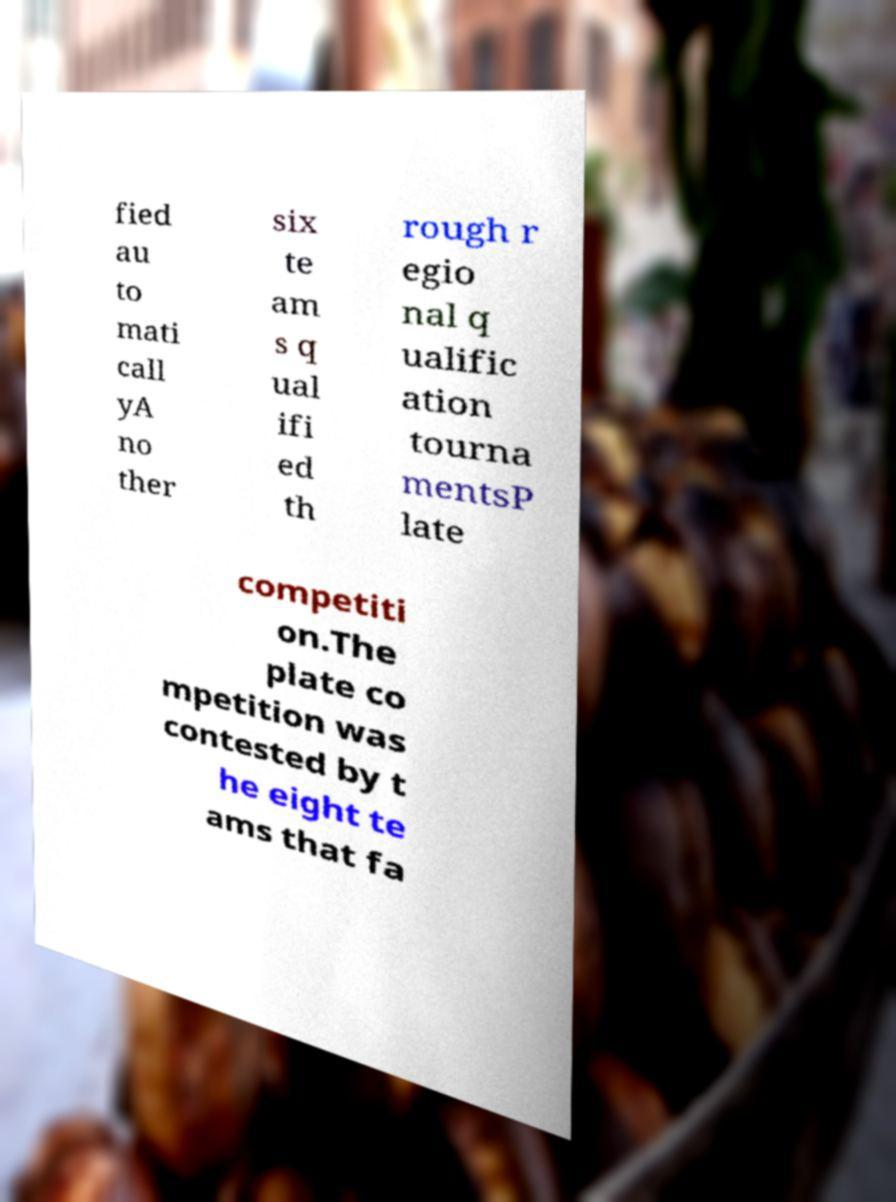Could you extract and type out the text from this image? fied au to mati call yA no ther six te am s q ual ifi ed th rough r egio nal q ualific ation tourna mentsP late competiti on.The plate co mpetition was contested by t he eight te ams that fa 